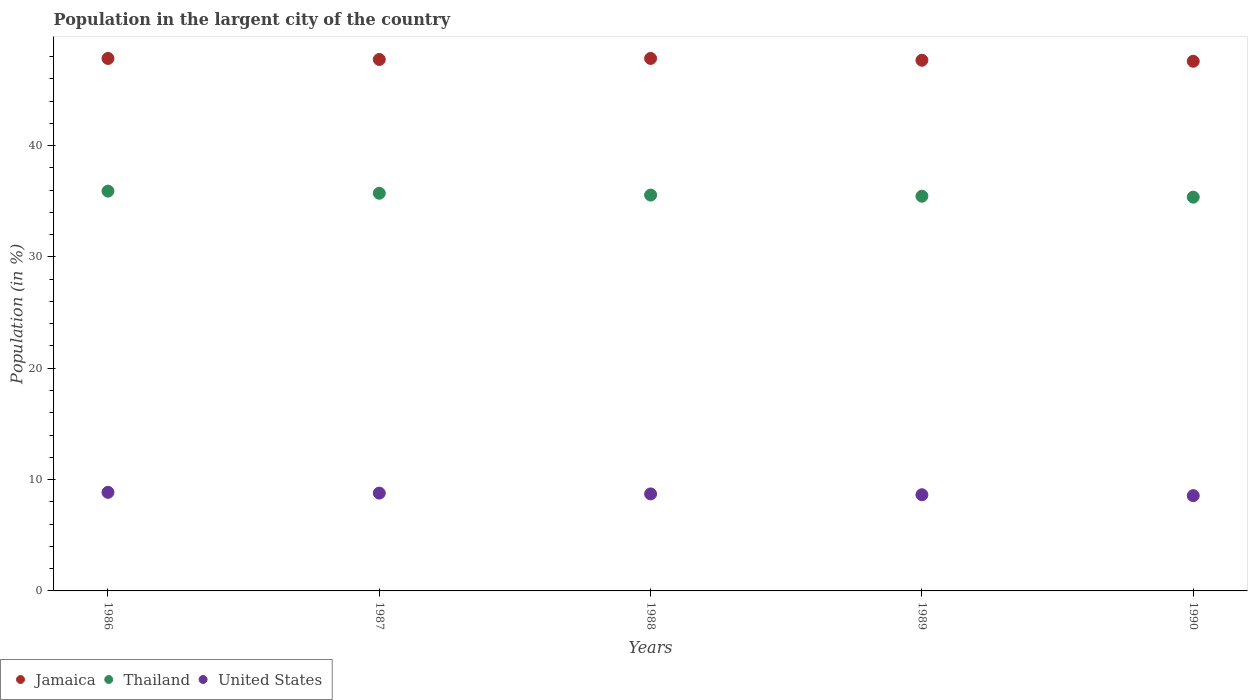How many different coloured dotlines are there?
Provide a succinct answer. 3. Is the number of dotlines equal to the number of legend labels?
Offer a very short reply. Yes. What is the percentage of population in the largent city in Jamaica in 1987?
Your response must be concise. 47.73. Across all years, what is the maximum percentage of population in the largent city in Thailand?
Make the answer very short. 35.91. Across all years, what is the minimum percentage of population in the largent city in United States?
Keep it short and to the point. 8.56. In which year was the percentage of population in the largent city in Jamaica maximum?
Your answer should be compact. 1988. What is the total percentage of population in the largent city in Thailand in the graph?
Your answer should be compact. 178. What is the difference between the percentage of population in the largent city in Jamaica in 1988 and that in 1989?
Keep it short and to the point. 0.16. What is the difference between the percentage of population in the largent city in United States in 1989 and the percentage of population in the largent city in Thailand in 1986?
Give a very brief answer. -27.27. What is the average percentage of population in the largent city in Thailand per year?
Your answer should be very brief. 35.6. In the year 1986, what is the difference between the percentage of population in the largent city in Thailand and percentage of population in the largent city in Jamaica?
Your answer should be very brief. -11.92. What is the ratio of the percentage of population in the largent city in United States in 1988 to that in 1989?
Offer a terse response. 1.01. Is the percentage of population in the largent city in United States in 1987 less than that in 1989?
Your response must be concise. No. Is the difference between the percentage of population in the largent city in Thailand in 1986 and 1989 greater than the difference between the percentage of population in the largent city in Jamaica in 1986 and 1989?
Provide a succinct answer. Yes. What is the difference between the highest and the second highest percentage of population in the largent city in Thailand?
Give a very brief answer. 0.19. What is the difference between the highest and the lowest percentage of population in the largent city in United States?
Provide a short and direct response. 0.3. Does the percentage of population in the largent city in Jamaica monotonically increase over the years?
Provide a short and direct response. No. How many years are there in the graph?
Your answer should be compact. 5. What is the difference between two consecutive major ticks on the Y-axis?
Make the answer very short. 10. Does the graph contain any zero values?
Provide a short and direct response. No. Does the graph contain grids?
Your response must be concise. No. Where does the legend appear in the graph?
Your response must be concise. Bottom left. How many legend labels are there?
Make the answer very short. 3. How are the legend labels stacked?
Keep it short and to the point. Horizontal. What is the title of the graph?
Provide a succinct answer. Population in the largent city of the country. Does "Burkina Faso" appear as one of the legend labels in the graph?
Offer a very short reply. No. What is the label or title of the X-axis?
Your answer should be very brief. Years. What is the label or title of the Y-axis?
Provide a succinct answer. Population (in %). What is the Population (in %) of Jamaica in 1986?
Ensure brevity in your answer.  47.83. What is the Population (in %) in Thailand in 1986?
Offer a very short reply. 35.91. What is the Population (in %) of United States in 1986?
Ensure brevity in your answer.  8.86. What is the Population (in %) of Jamaica in 1987?
Offer a terse response. 47.73. What is the Population (in %) of Thailand in 1987?
Keep it short and to the point. 35.72. What is the Population (in %) of United States in 1987?
Provide a short and direct response. 8.78. What is the Population (in %) of Jamaica in 1988?
Make the answer very short. 47.83. What is the Population (in %) in Thailand in 1988?
Your answer should be very brief. 35.55. What is the Population (in %) of United States in 1988?
Ensure brevity in your answer.  8.71. What is the Population (in %) in Jamaica in 1989?
Give a very brief answer. 47.66. What is the Population (in %) in Thailand in 1989?
Ensure brevity in your answer.  35.45. What is the Population (in %) in United States in 1989?
Ensure brevity in your answer.  8.64. What is the Population (in %) in Jamaica in 1990?
Keep it short and to the point. 47.57. What is the Population (in %) of Thailand in 1990?
Ensure brevity in your answer.  35.37. What is the Population (in %) in United States in 1990?
Make the answer very short. 8.56. Across all years, what is the maximum Population (in %) of Jamaica?
Your response must be concise. 47.83. Across all years, what is the maximum Population (in %) of Thailand?
Ensure brevity in your answer.  35.91. Across all years, what is the maximum Population (in %) of United States?
Offer a very short reply. 8.86. Across all years, what is the minimum Population (in %) of Jamaica?
Make the answer very short. 47.57. Across all years, what is the minimum Population (in %) in Thailand?
Give a very brief answer. 35.37. Across all years, what is the minimum Population (in %) of United States?
Keep it short and to the point. 8.56. What is the total Population (in %) of Jamaica in the graph?
Your response must be concise. 238.62. What is the total Population (in %) in Thailand in the graph?
Your answer should be very brief. 178. What is the total Population (in %) in United States in the graph?
Provide a short and direct response. 43.55. What is the difference between the Population (in %) in Jamaica in 1986 and that in 1987?
Provide a short and direct response. 0.09. What is the difference between the Population (in %) of Thailand in 1986 and that in 1987?
Provide a short and direct response. 0.19. What is the difference between the Population (in %) in United States in 1986 and that in 1987?
Provide a short and direct response. 0.07. What is the difference between the Population (in %) in Jamaica in 1986 and that in 1988?
Make the answer very short. -0. What is the difference between the Population (in %) of Thailand in 1986 and that in 1988?
Offer a terse response. 0.36. What is the difference between the Population (in %) in United States in 1986 and that in 1988?
Make the answer very short. 0.14. What is the difference between the Population (in %) of Jamaica in 1986 and that in 1989?
Offer a terse response. 0.16. What is the difference between the Population (in %) of Thailand in 1986 and that in 1989?
Your response must be concise. 0.46. What is the difference between the Population (in %) in United States in 1986 and that in 1989?
Provide a succinct answer. 0.22. What is the difference between the Population (in %) in Jamaica in 1986 and that in 1990?
Give a very brief answer. 0.25. What is the difference between the Population (in %) in Thailand in 1986 and that in 1990?
Keep it short and to the point. 0.54. What is the difference between the Population (in %) of United States in 1986 and that in 1990?
Your answer should be compact. 0.3. What is the difference between the Population (in %) of Jamaica in 1987 and that in 1988?
Ensure brevity in your answer.  -0.09. What is the difference between the Population (in %) of Thailand in 1987 and that in 1988?
Ensure brevity in your answer.  0.16. What is the difference between the Population (in %) of United States in 1987 and that in 1988?
Keep it short and to the point. 0.07. What is the difference between the Population (in %) in Jamaica in 1987 and that in 1989?
Keep it short and to the point. 0.07. What is the difference between the Population (in %) in Thailand in 1987 and that in 1989?
Ensure brevity in your answer.  0.27. What is the difference between the Population (in %) of United States in 1987 and that in 1989?
Give a very brief answer. 0.15. What is the difference between the Population (in %) of Jamaica in 1987 and that in 1990?
Offer a terse response. 0.16. What is the difference between the Population (in %) of Thailand in 1987 and that in 1990?
Make the answer very short. 0.35. What is the difference between the Population (in %) in United States in 1987 and that in 1990?
Your answer should be compact. 0.23. What is the difference between the Population (in %) of Jamaica in 1988 and that in 1989?
Offer a very short reply. 0.16. What is the difference between the Population (in %) of Thailand in 1988 and that in 1989?
Give a very brief answer. 0.1. What is the difference between the Population (in %) in United States in 1988 and that in 1989?
Offer a very short reply. 0.07. What is the difference between the Population (in %) of Jamaica in 1988 and that in 1990?
Provide a short and direct response. 0.25. What is the difference between the Population (in %) in Thailand in 1988 and that in 1990?
Give a very brief answer. 0.19. What is the difference between the Population (in %) of United States in 1988 and that in 1990?
Provide a short and direct response. 0.15. What is the difference between the Population (in %) of Jamaica in 1989 and that in 1990?
Make the answer very short. 0.09. What is the difference between the Population (in %) in Thailand in 1989 and that in 1990?
Your answer should be very brief. 0.08. What is the difference between the Population (in %) in United States in 1989 and that in 1990?
Give a very brief answer. 0.08. What is the difference between the Population (in %) in Jamaica in 1986 and the Population (in %) in Thailand in 1987?
Your response must be concise. 12.11. What is the difference between the Population (in %) of Jamaica in 1986 and the Population (in %) of United States in 1987?
Ensure brevity in your answer.  39.04. What is the difference between the Population (in %) in Thailand in 1986 and the Population (in %) in United States in 1987?
Keep it short and to the point. 27.13. What is the difference between the Population (in %) in Jamaica in 1986 and the Population (in %) in Thailand in 1988?
Make the answer very short. 12.27. What is the difference between the Population (in %) in Jamaica in 1986 and the Population (in %) in United States in 1988?
Offer a very short reply. 39.11. What is the difference between the Population (in %) in Thailand in 1986 and the Population (in %) in United States in 1988?
Provide a short and direct response. 27.2. What is the difference between the Population (in %) in Jamaica in 1986 and the Population (in %) in Thailand in 1989?
Offer a terse response. 12.38. What is the difference between the Population (in %) of Jamaica in 1986 and the Population (in %) of United States in 1989?
Give a very brief answer. 39.19. What is the difference between the Population (in %) in Thailand in 1986 and the Population (in %) in United States in 1989?
Make the answer very short. 27.27. What is the difference between the Population (in %) in Jamaica in 1986 and the Population (in %) in Thailand in 1990?
Your answer should be compact. 12.46. What is the difference between the Population (in %) of Jamaica in 1986 and the Population (in %) of United States in 1990?
Give a very brief answer. 39.27. What is the difference between the Population (in %) in Thailand in 1986 and the Population (in %) in United States in 1990?
Your response must be concise. 27.35. What is the difference between the Population (in %) of Jamaica in 1987 and the Population (in %) of Thailand in 1988?
Your answer should be very brief. 12.18. What is the difference between the Population (in %) in Jamaica in 1987 and the Population (in %) in United States in 1988?
Ensure brevity in your answer.  39.02. What is the difference between the Population (in %) in Thailand in 1987 and the Population (in %) in United States in 1988?
Make the answer very short. 27.01. What is the difference between the Population (in %) in Jamaica in 1987 and the Population (in %) in Thailand in 1989?
Your answer should be very brief. 12.28. What is the difference between the Population (in %) in Jamaica in 1987 and the Population (in %) in United States in 1989?
Give a very brief answer. 39.09. What is the difference between the Population (in %) of Thailand in 1987 and the Population (in %) of United States in 1989?
Give a very brief answer. 27.08. What is the difference between the Population (in %) of Jamaica in 1987 and the Population (in %) of Thailand in 1990?
Give a very brief answer. 12.37. What is the difference between the Population (in %) of Jamaica in 1987 and the Population (in %) of United States in 1990?
Provide a short and direct response. 39.18. What is the difference between the Population (in %) in Thailand in 1987 and the Population (in %) in United States in 1990?
Keep it short and to the point. 27.16. What is the difference between the Population (in %) in Jamaica in 1988 and the Population (in %) in Thailand in 1989?
Provide a succinct answer. 12.38. What is the difference between the Population (in %) in Jamaica in 1988 and the Population (in %) in United States in 1989?
Ensure brevity in your answer.  39.19. What is the difference between the Population (in %) of Thailand in 1988 and the Population (in %) of United States in 1989?
Your response must be concise. 26.92. What is the difference between the Population (in %) in Jamaica in 1988 and the Population (in %) in Thailand in 1990?
Your response must be concise. 12.46. What is the difference between the Population (in %) in Jamaica in 1988 and the Population (in %) in United States in 1990?
Your answer should be very brief. 39.27. What is the difference between the Population (in %) of Thailand in 1988 and the Population (in %) of United States in 1990?
Make the answer very short. 27. What is the difference between the Population (in %) in Jamaica in 1989 and the Population (in %) in Thailand in 1990?
Ensure brevity in your answer.  12.3. What is the difference between the Population (in %) of Jamaica in 1989 and the Population (in %) of United States in 1990?
Offer a terse response. 39.11. What is the difference between the Population (in %) of Thailand in 1989 and the Population (in %) of United States in 1990?
Offer a terse response. 26.89. What is the average Population (in %) of Jamaica per year?
Make the answer very short. 47.72. What is the average Population (in %) of Thailand per year?
Your answer should be very brief. 35.6. What is the average Population (in %) in United States per year?
Your answer should be very brief. 8.71. In the year 1986, what is the difference between the Population (in %) in Jamaica and Population (in %) in Thailand?
Provide a short and direct response. 11.92. In the year 1986, what is the difference between the Population (in %) in Jamaica and Population (in %) in United States?
Your answer should be very brief. 38.97. In the year 1986, what is the difference between the Population (in %) of Thailand and Population (in %) of United States?
Your answer should be compact. 27.05. In the year 1987, what is the difference between the Population (in %) in Jamaica and Population (in %) in Thailand?
Offer a terse response. 12.02. In the year 1987, what is the difference between the Population (in %) in Jamaica and Population (in %) in United States?
Provide a short and direct response. 38.95. In the year 1987, what is the difference between the Population (in %) of Thailand and Population (in %) of United States?
Keep it short and to the point. 26.93. In the year 1988, what is the difference between the Population (in %) of Jamaica and Population (in %) of Thailand?
Keep it short and to the point. 12.27. In the year 1988, what is the difference between the Population (in %) in Jamaica and Population (in %) in United States?
Provide a succinct answer. 39.11. In the year 1988, what is the difference between the Population (in %) in Thailand and Population (in %) in United States?
Provide a short and direct response. 26.84. In the year 1989, what is the difference between the Population (in %) of Jamaica and Population (in %) of Thailand?
Your response must be concise. 12.21. In the year 1989, what is the difference between the Population (in %) of Jamaica and Population (in %) of United States?
Make the answer very short. 39.02. In the year 1989, what is the difference between the Population (in %) of Thailand and Population (in %) of United States?
Give a very brief answer. 26.81. In the year 1990, what is the difference between the Population (in %) in Jamaica and Population (in %) in Thailand?
Keep it short and to the point. 12.2. In the year 1990, what is the difference between the Population (in %) of Jamaica and Population (in %) of United States?
Your response must be concise. 39.01. In the year 1990, what is the difference between the Population (in %) in Thailand and Population (in %) in United States?
Provide a succinct answer. 26.81. What is the ratio of the Population (in %) of Jamaica in 1986 to that in 1987?
Keep it short and to the point. 1. What is the ratio of the Population (in %) in Thailand in 1986 to that in 1987?
Give a very brief answer. 1.01. What is the ratio of the Population (in %) of United States in 1986 to that in 1987?
Your answer should be compact. 1.01. What is the ratio of the Population (in %) in Thailand in 1986 to that in 1988?
Give a very brief answer. 1.01. What is the ratio of the Population (in %) in United States in 1986 to that in 1988?
Provide a succinct answer. 1.02. What is the ratio of the Population (in %) in Thailand in 1986 to that in 1989?
Your answer should be compact. 1.01. What is the ratio of the Population (in %) in United States in 1986 to that in 1989?
Your answer should be compact. 1.03. What is the ratio of the Population (in %) in Jamaica in 1986 to that in 1990?
Offer a very short reply. 1.01. What is the ratio of the Population (in %) in Thailand in 1986 to that in 1990?
Give a very brief answer. 1.02. What is the ratio of the Population (in %) in United States in 1986 to that in 1990?
Ensure brevity in your answer.  1.03. What is the ratio of the Population (in %) in Jamaica in 1987 to that in 1988?
Your response must be concise. 1. What is the ratio of the Population (in %) of United States in 1987 to that in 1988?
Your answer should be compact. 1.01. What is the ratio of the Population (in %) in Thailand in 1987 to that in 1989?
Your response must be concise. 1.01. What is the ratio of the Population (in %) in United States in 1987 to that in 1989?
Provide a short and direct response. 1.02. What is the ratio of the Population (in %) in Thailand in 1987 to that in 1990?
Provide a succinct answer. 1.01. What is the ratio of the Population (in %) of United States in 1987 to that in 1990?
Your response must be concise. 1.03. What is the ratio of the Population (in %) of Jamaica in 1988 to that in 1989?
Offer a very short reply. 1. What is the ratio of the Population (in %) in Thailand in 1988 to that in 1989?
Provide a succinct answer. 1. What is the ratio of the Population (in %) of United States in 1988 to that in 1989?
Your response must be concise. 1.01. What is the ratio of the Population (in %) of Thailand in 1988 to that in 1990?
Your answer should be very brief. 1.01. What is the ratio of the Population (in %) in United States in 1988 to that in 1990?
Your answer should be very brief. 1.02. What is the ratio of the Population (in %) in Thailand in 1989 to that in 1990?
Keep it short and to the point. 1. What is the ratio of the Population (in %) in United States in 1989 to that in 1990?
Ensure brevity in your answer.  1.01. What is the difference between the highest and the second highest Population (in %) of Jamaica?
Your answer should be very brief. 0. What is the difference between the highest and the second highest Population (in %) of Thailand?
Make the answer very short. 0.19. What is the difference between the highest and the second highest Population (in %) in United States?
Your answer should be compact. 0.07. What is the difference between the highest and the lowest Population (in %) in Jamaica?
Your answer should be very brief. 0.25. What is the difference between the highest and the lowest Population (in %) in Thailand?
Offer a terse response. 0.54. What is the difference between the highest and the lowest Population (in %) of United States?
Provide a short and direct response. 0.3. 